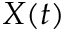<formula> <loc_0><loc_0><loc_500><loc_500>X ( t )</formula> 